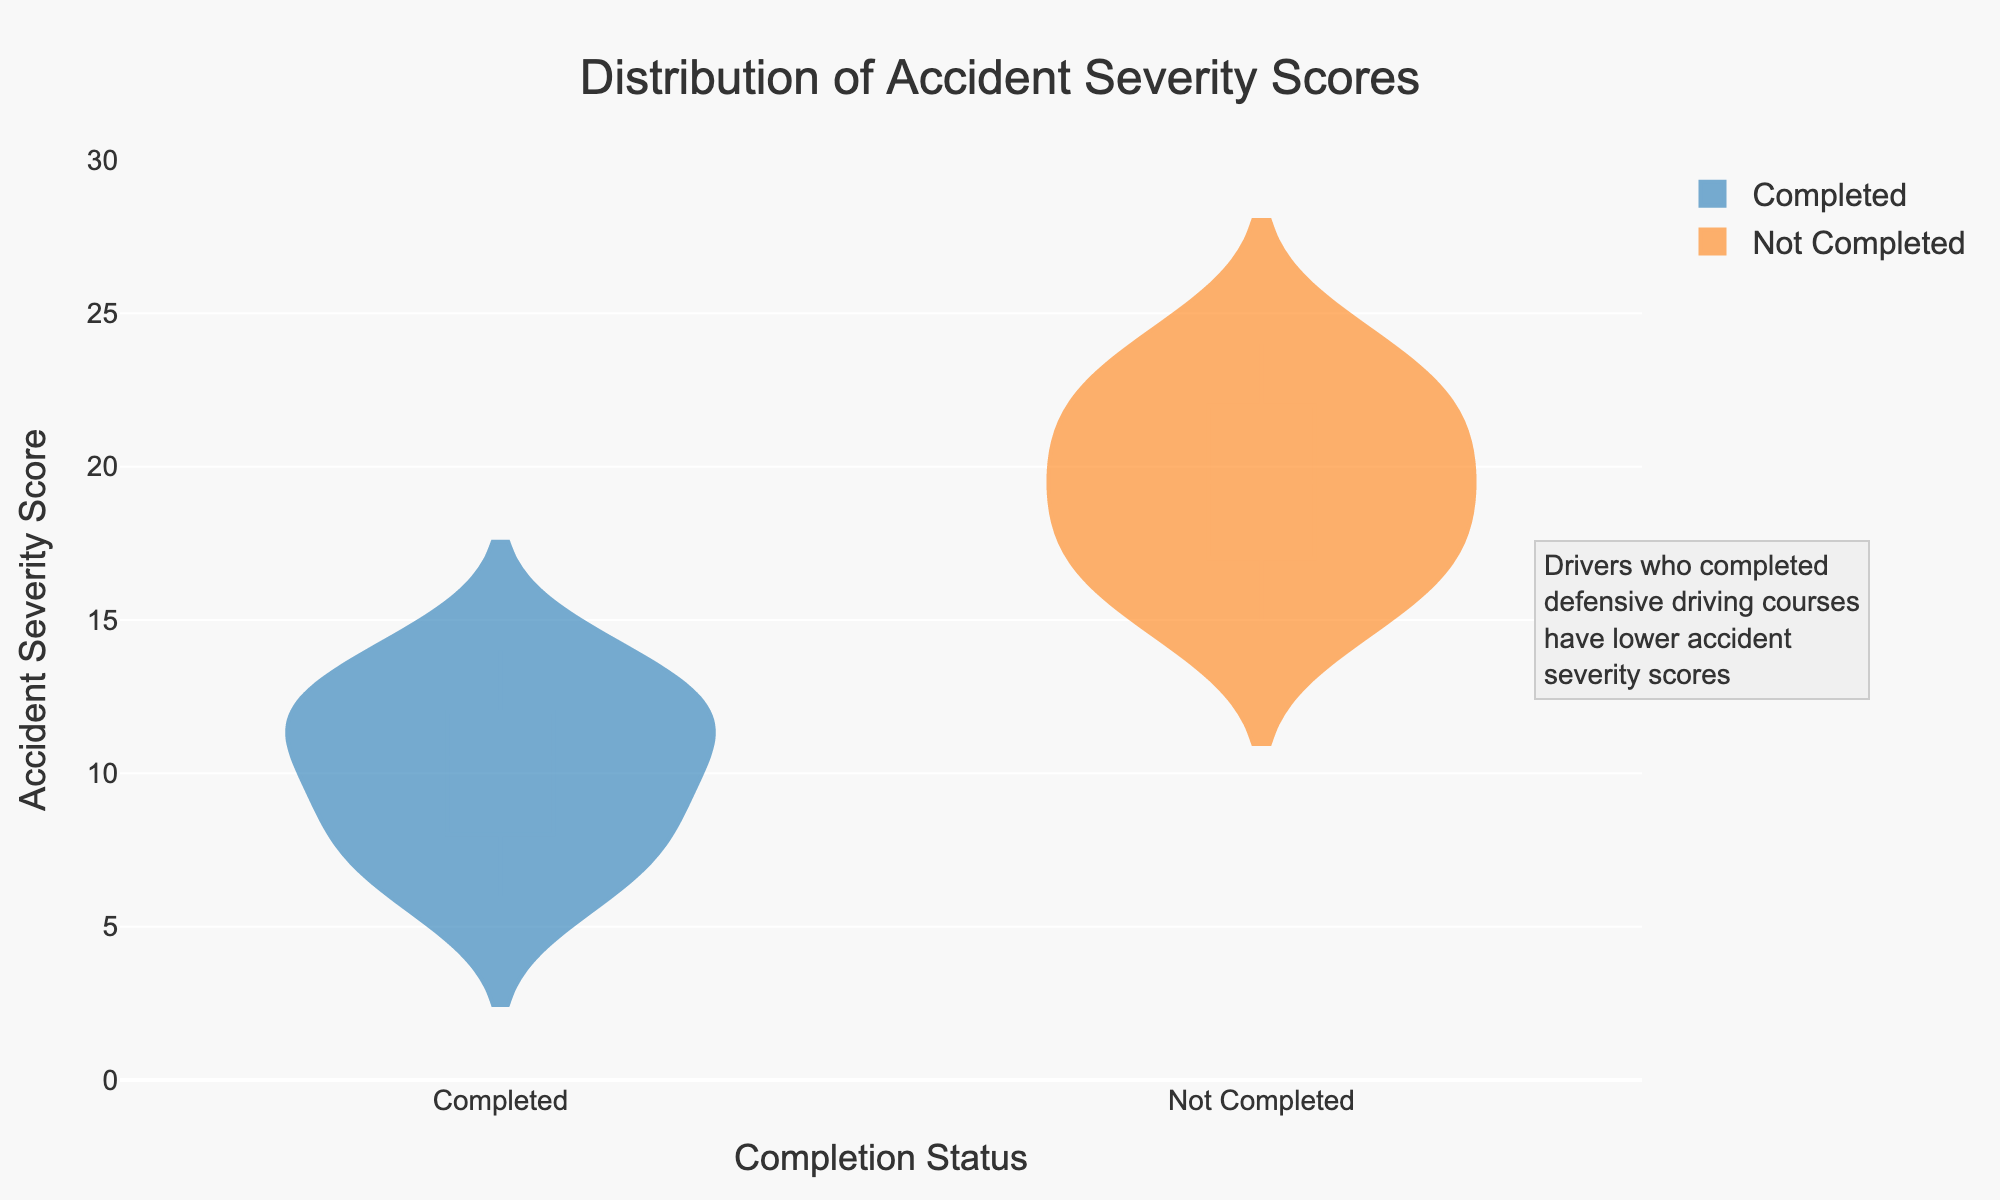What's the title of the figure? The title of the figure is displayed at the top and provides a summary of the content. Reading the top part of the figure, you can see "Distribution of Accident Severity Scores."
Answer: Distribution of Accident Severity Scores What is the y-axis title? The y-axis title is located on the vertical axis and describes what the y-axis represents. By looking at the vertical axis, you can see that it is labeled "Accident Severity Score."
Answer: Accident Severity Score Which group has higher median accident severity scores? The violin plots include box plots that show the median values. For the "Not Completed" group, the median line appears higher on the y-axis compared to the "Completed" group.
Answer: Not Completed What color represents the drivers who completed the defensive driving courses? The color of the violin plot corresponding to the "Completed" group can be identified. The "Completed" group is represented by a shade of blue.
Answer: Blue Are there outliers present in the accident severity scores for each group? Outliers can usually be identified in violin plots as points that fall outside the typical range of the distribution. Observing the figure, we can see there are no distinct outlier points shown.
Answer: No What's the range of accident severity scores for drivers who have not completed the course? The range can be found by looking at the bottom and top edges of the violin plot for the "Not Completed" group. The scores span approximately from 15 to 24.
Answer: 15 to 24 What's the difference between the median accident severity scores of the two groups? The median can be found as the line in the middle of each box plot in the violin charts. The "Completed" group has a median around 10, and the "Not Completed" group has a median around 20. The difference is 20 - 10 = 10.
Answer: 10 Which group shows a wider distribution of accident severity scores? The distribution's width can be observed by the spread of the violin plot. The "Not Completed" group has a wider spread from 15 to 24 compared to the "Completed" group.
Answer: Not Completed What is the maximum accident severity score observed for drivers who completed the course? This can be identified by looking at the top of the violin plot for the "Completed" group. The maximum value appears to be around 14.
Answer: 14 How do the annotations help in understanding the figure? The annotations are typically included to provide additional context or insights. In this figure, the annotation explains that "Drivers who completed defensive driving courses have lower accident severity scores," which helps in understanding the observed patterns.
Answer: They clarify the insights 